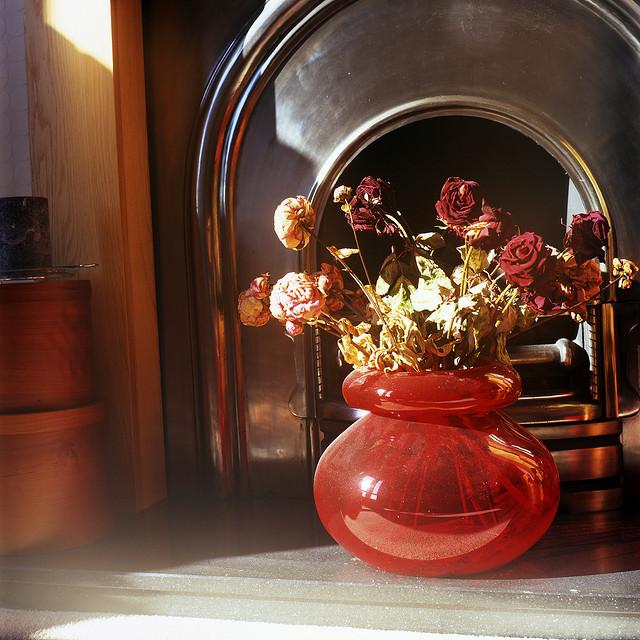What kind of flowers are there?
Concise answer only. Roses. What color is the vase?
Keep it brief. Red. What is in the vase?
Concise answer only. Flowers. 